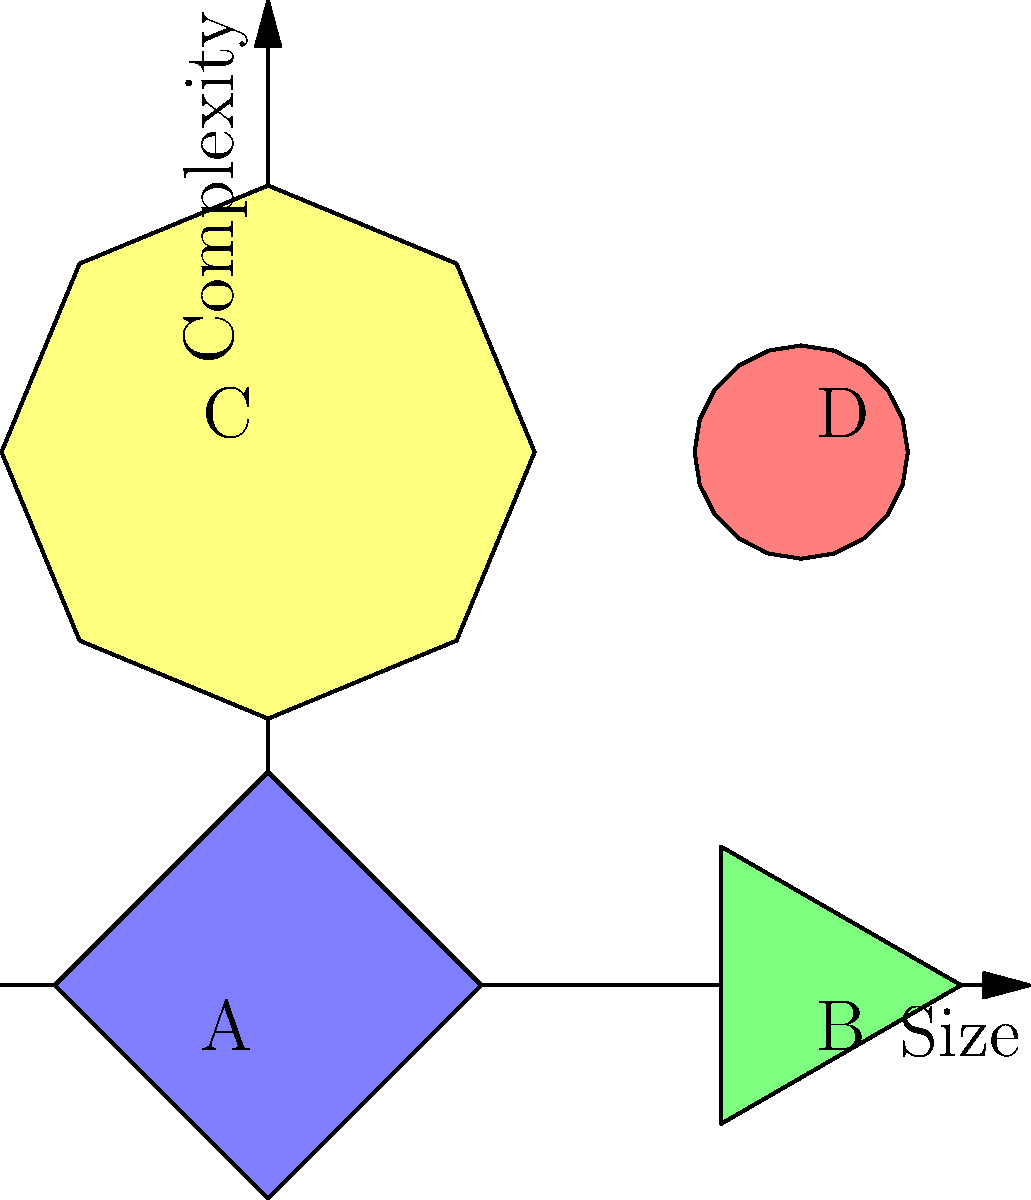Based on the satellite imagery of space debris objects shown in the graph, which object is most likely to be a large, complex satellite fragment, and why? To determine which object is most likely to be a large, complex satellite fragment, we need to analyze each object based on its size and complexity:

1. Object A (bottom-left):
   - Medium size
   - Low complexity (square shape)

2. Object B (bottom-right):
   - Small size
   - Low complexity (triangular shape)

3. Object C (top-left):
   - Large size
   - Medium complexity (octagonal shape)

4. Object D (top-right):
   - Small size
   - High complexity (nearly circular shape with many sides)

A large, complex satellite fragment would typically have:
a) A relatively large size, as it comes from a substantial piece of a satellite
b) High complexity, due to the intricate structures and components of satellites

Comparing these criteria to our objects:
- Object C has the largest size, which matches the "large" criterion
- Object C also has a more complex shape than A and B, indicating it's likely a fragment with multiple components

While Object D has the highest complexity, its small size makes it less likely to be a large satellite fragment.

Therefore, Object C best fits the description of a large, complex satellite fragment.
Answer: Object C 